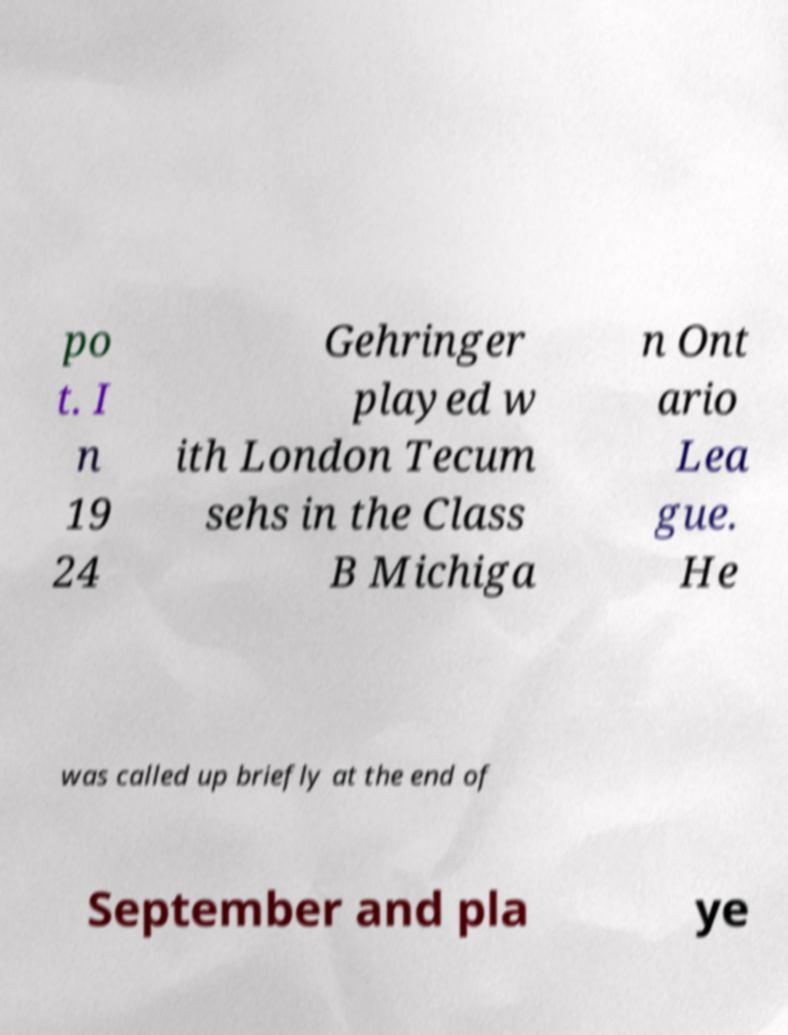Could you extract and type out the text from this image? po t. I n 19 24 Gehringer played w ith London Tecum sehs in the Class B Michiga n Ont ario Lea gue. He was called up briefly at the end of September and pla ye 